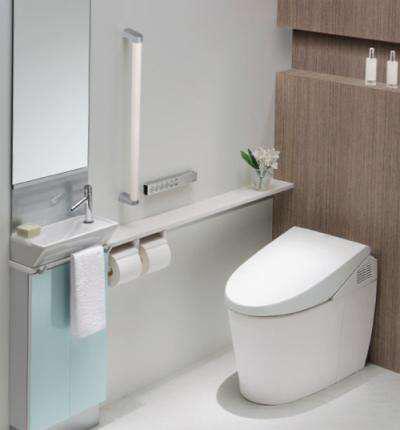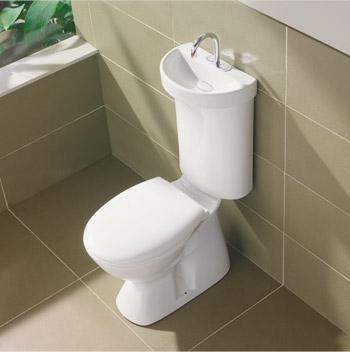The first image is the image on the left, the second image is the image on the right. For the images displayed, is the sentence "At least one toilet is visible in every picture and all toilets have their lids closed." factually correct? Answer yes or no. Yes. 